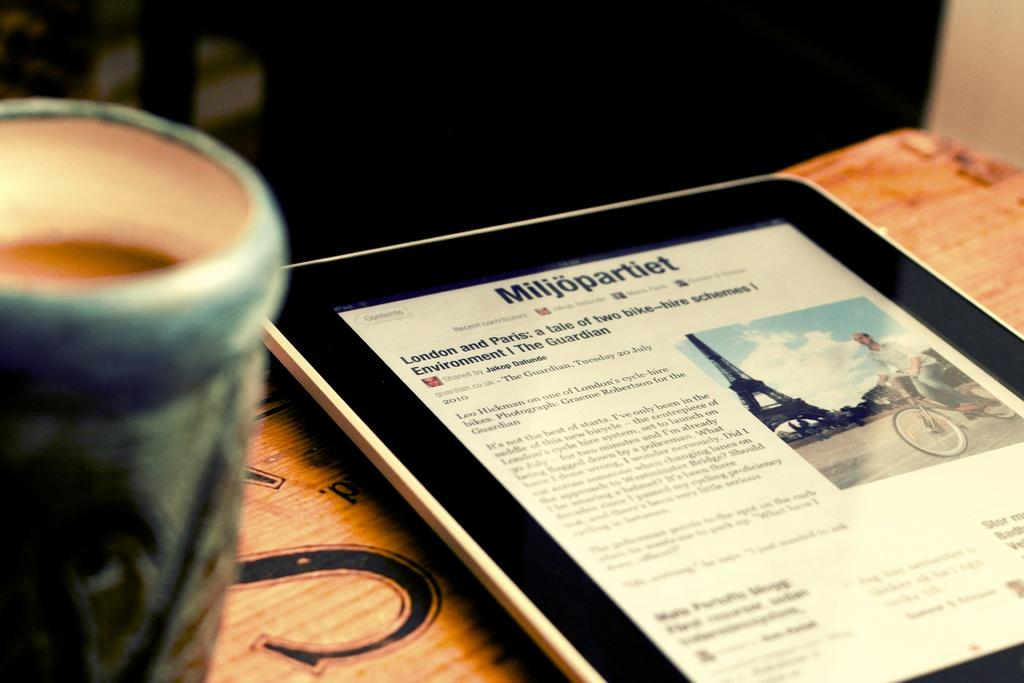<image>
Give a short and clear explanation of the subsequent image. A tablet displays a news story about bike hire schemes in London and Paris. 